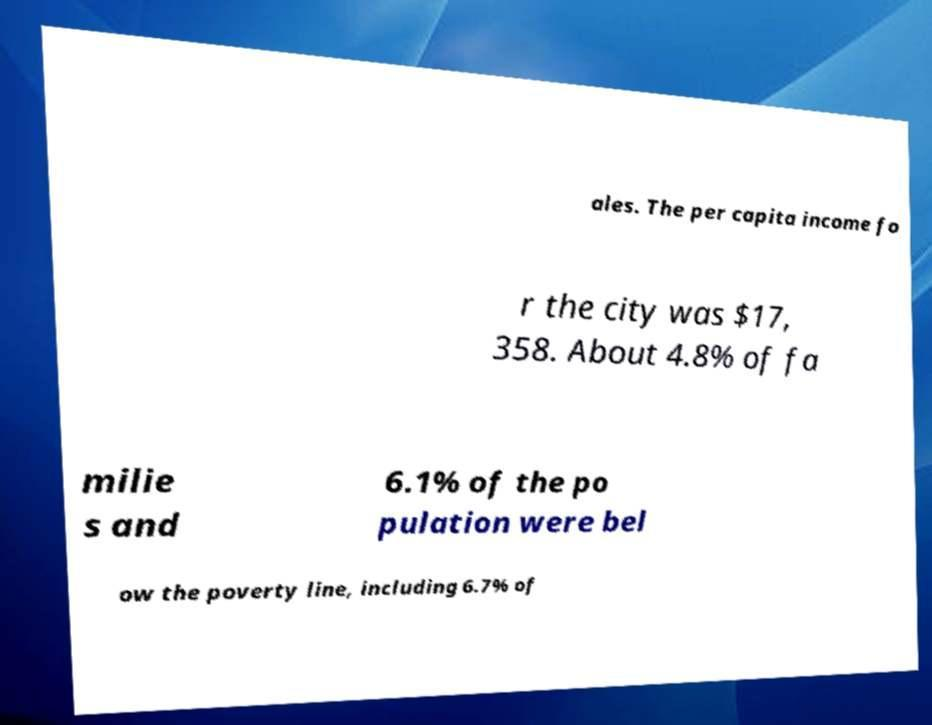Could you extract and type out the text from this image? ales. The per capita income fo r the city was $17, 358. About 4.8% of fa milie s and 6.1% of the po pulation were bel ow the poverty line, including 6.7% of 